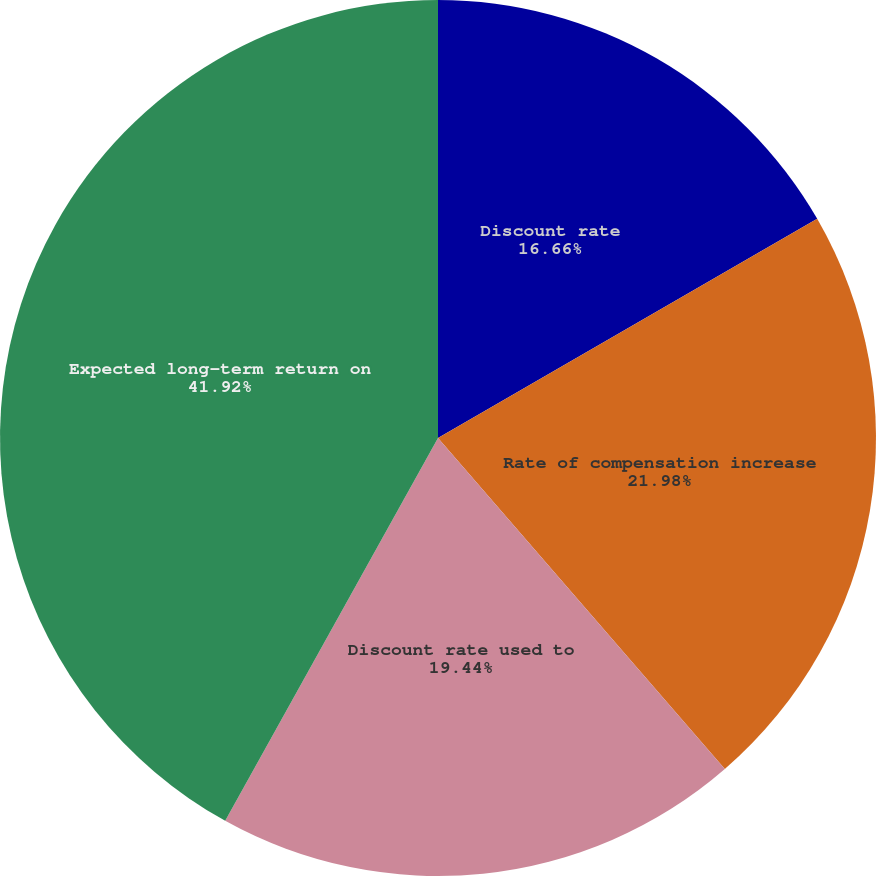Convert chart. <chart><loc_0><loc_0><loc_500><loc_500><pie_chart><fcel>Discount rate<fcel>Rate of compensation increase<fcel>Discount rate used to<fcel>Expected long-term return on<nl><fcel>16.66%<fcel>21.98%<fcel>19.44%<fcel>41.93%<nl></chart> 